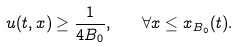Convert formula to latex. <formula><loc_0><loc_0><loc_500><loc_500>u ( t , x ) \geq \frac { 1 } { 4 B _ { 0 } } , \quad \forall x \leq x _ { B _ { 0 } } ( t ) .</formula> 